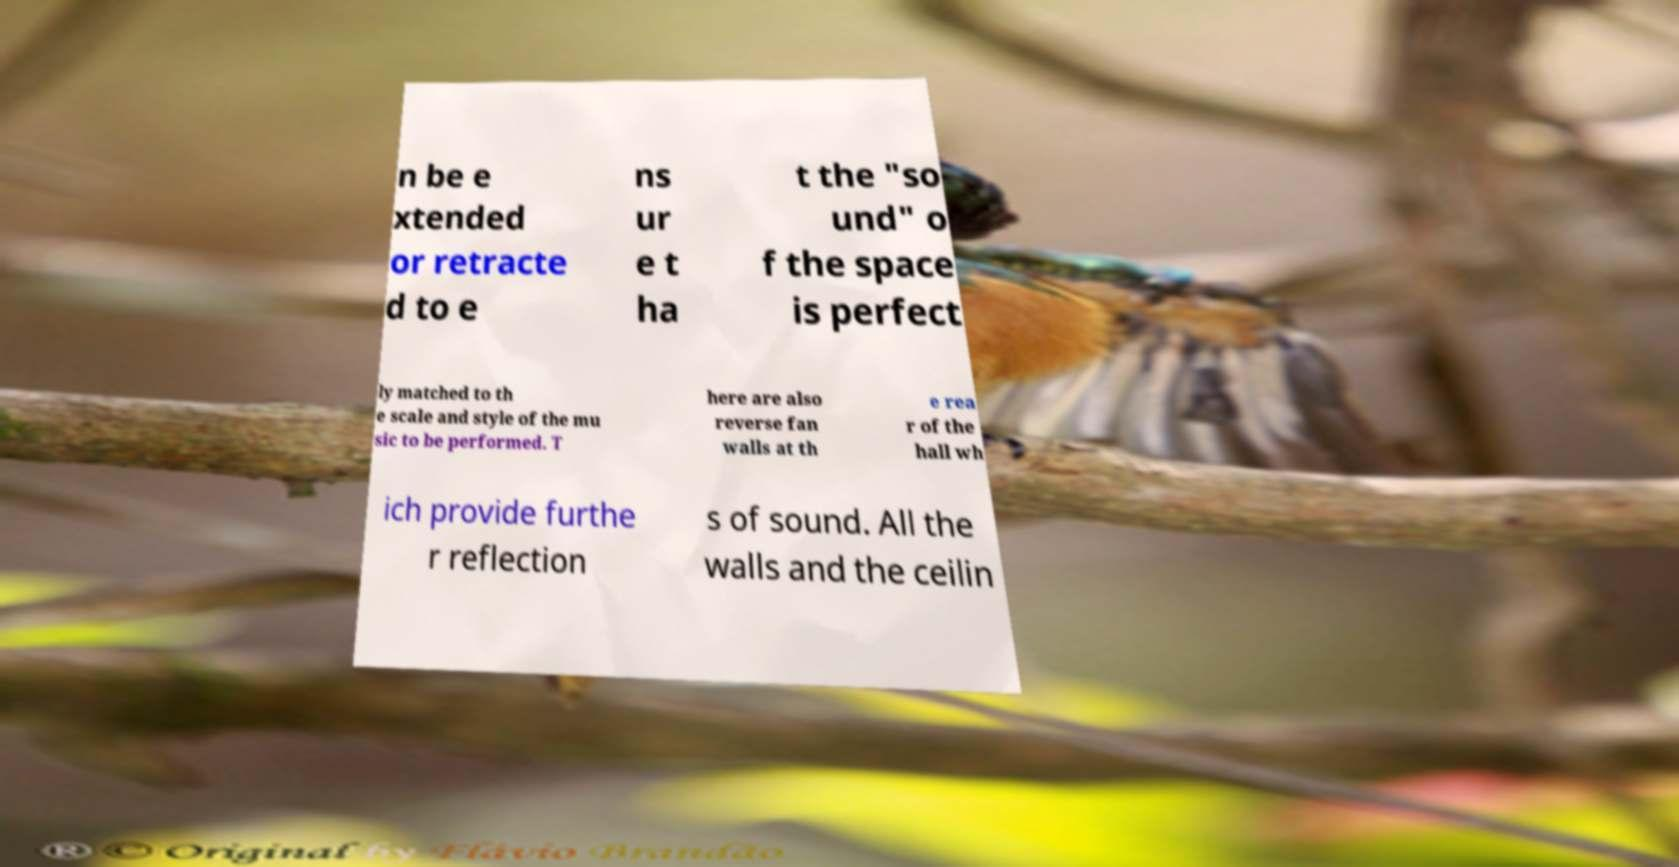Could you extract and type out the text from this image? n be e xtended or retracte d to e ns ur e t ha t the "so und" o f the space is perfect ly matched to th e scale and style of the mu sic to be performed. T here are also reverse fan walls at th e rea r of the hall wh ich provide furthe r reflection s of sound. All the walls and the ceilin 